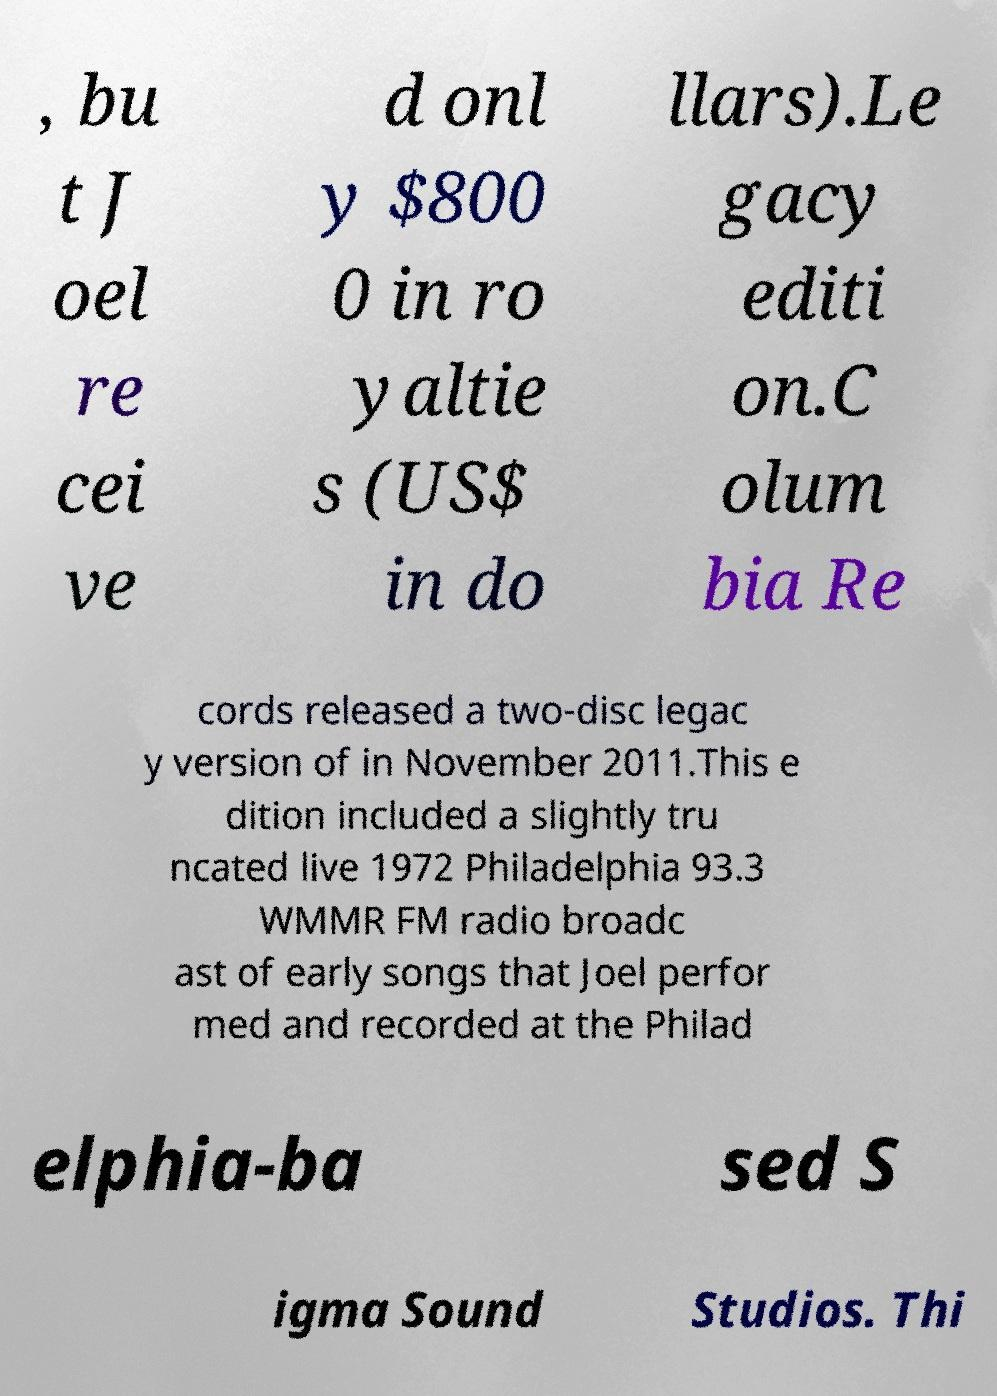What messages or text are displayed in this image? I need them in a readable, typed format. , bu t J oel re cei ve d onl y $800 0 in ro yaltie s (US$ in do llars).Le gacy editi on.C olum bia Re cords released a two-disc legac y version of in November 2011.This e dition included a slightly tru ncated live 1972 Philadelphia 93.3 WMMR FM radio broadc ast of early songs that Joel perfor med and recorded at the Philad elphia-ba sed S igma Sound Studios. Thi 